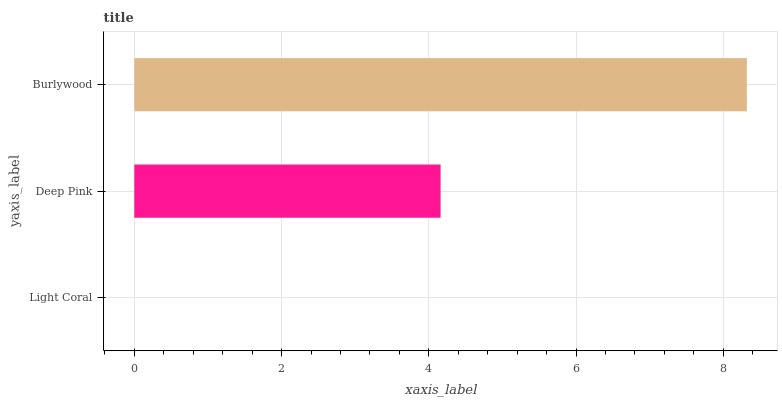Is Light Coral the minimum?
Answer yes or no. Yes. Is Burlywood the maximum?
Answer yes or no. Yes. Is Deep Pink the minimum?
Answer yes or no. No. Is Deep Pink the maximum?
Answer yes or no. No. Is Deep Pink greater than Light Coral?
Answer yes or no. Yes. Is Light Coral less than Deep Pink?
Answer yes or no. Yes. Is Light Coral greater than Deep Pink?
Answer yes or no. No. Is Deep Pink less than Light Coral?
Answer yes or no. No. Is Deep Pink the high median?
Answer yes or no. Yes. Is Deep Pink the low median?
Answer yes or no. Yes. Is Light Coral the high median?
Answer yes or no. No. Is Burlywood the low median?
Answer yes or no. No. 